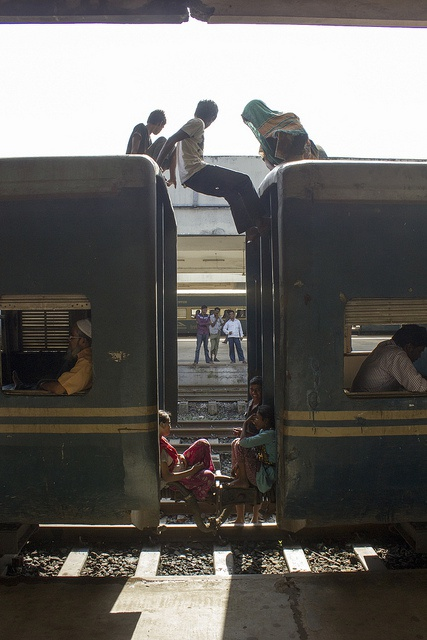Describe the objects in this image and their specific colors. I can see train in black and gray tones, people in black, gray, and darkgray tones, people in black and gray tones, people in black, maroon, and gray tones, and people in black, maroon, and gray tones in this image. 